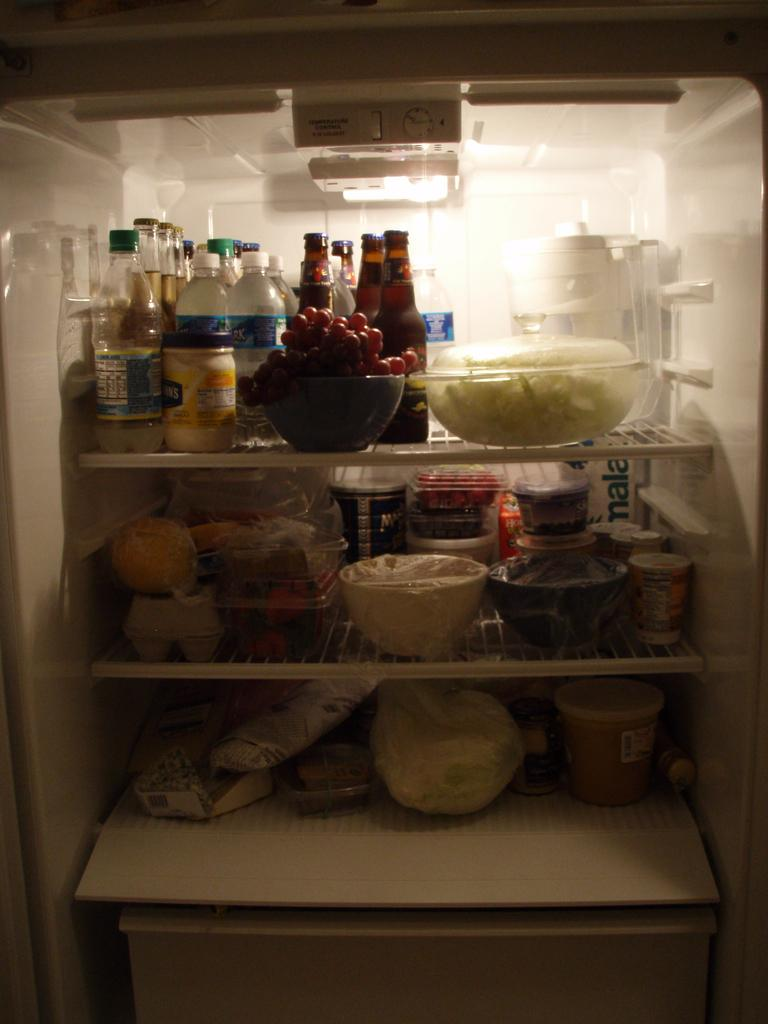<image>
Provide a brief description of the given image. A full fridge with a box in it that has the word mala on it 